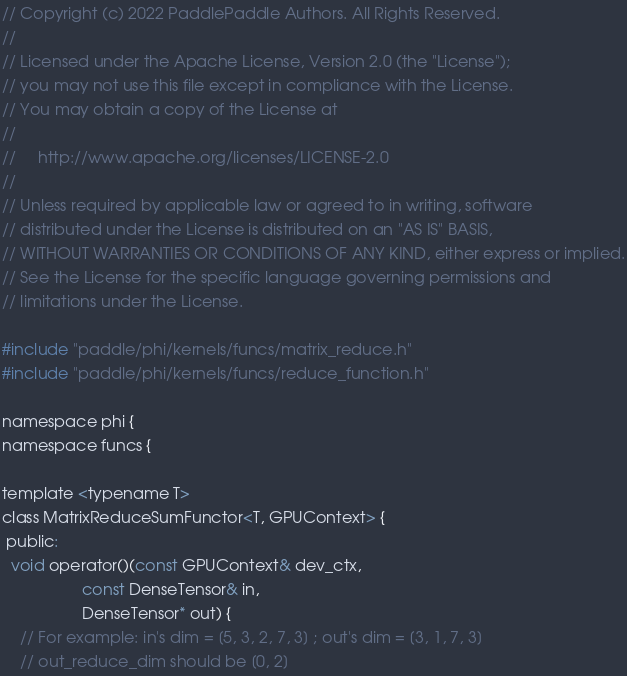<code> <loc_0><loc_0><loc_500><loc_500><_Cuda_>// Copyright (c) 2022 PaddlePaddle Authors. All Rights Reserved.
//
// Licensed under the Apache License, Version 2.0 (the "License");
// you may not use this file except in compliance with the License.
// You may obtain a copy of the License at
//
//     http://www.apache.org/licenses/LICENSE-2.0
//
// Unless required by applicable law or agreed to in writing, software
// distributed under the License is distributed on an "AS IS" BASIS,
// WITHOUT WARRANTIES OR CONDITIONS OF ANY KIND, either express or implied.
// See the License for the specific language governing permissions and
// limitations under the License.

#include "paddle/phi/kernels/funcs/matrix_reduce.h"
#include "paddle/phi/kernels/funcs/reduce_function.h"

namespace phi {
namespace funcs {

template <typename T>
class MatrixReduceSumFunctor<T, GPUContext> {
 public:
  void operator()(const GPUContext& dev_ctx,
                  const DenseTensor& in,
                  DenseTensor* out) {
    // For example: in's dim = [5, 3, 2, 7, 3] ; out's dim = [3, 1, 7, 3]
    // out_reduce_dim should be [0, 2]</code> 